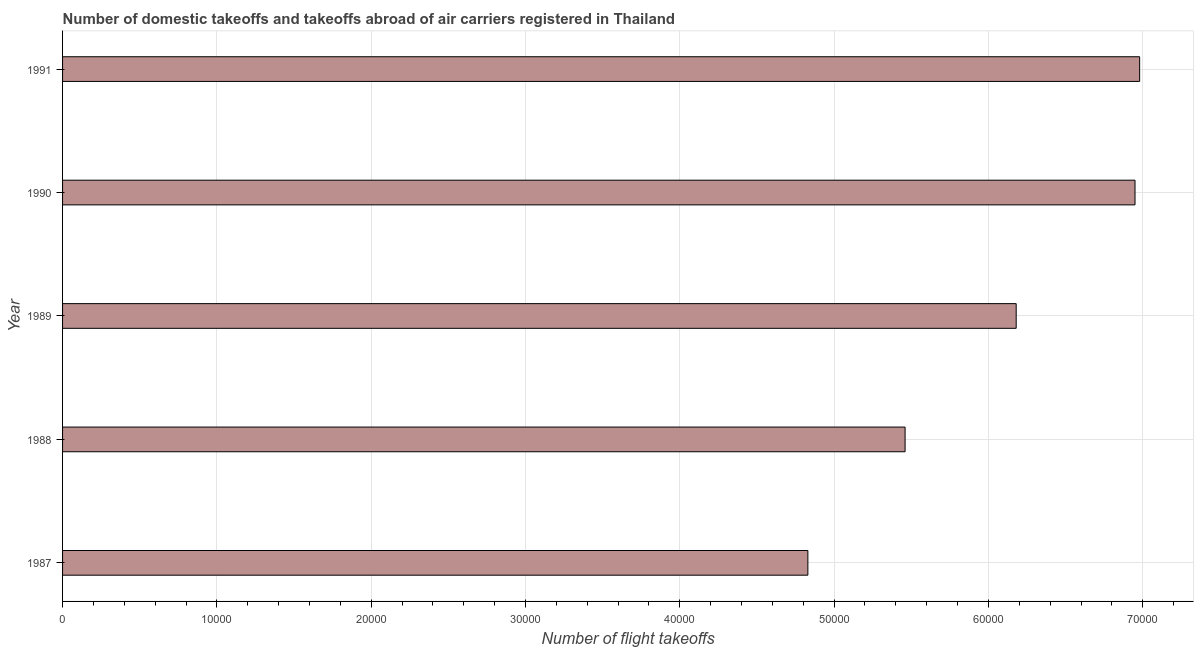Does the graph contain any zero values?
Provide a succinct answer. No. What is the title of the graph?
Keep it short and to the point. Number of domestic takeoffs and takeoffs abroad of air carriers registered in Thailand. What is the label or title of the X-axis?
Your answer should be very brief. Number of flight takeoffs. What is the number of flight takeoffs in 1990?
Offer a very short reply. 6.95e+04. Across all years, what is the maximum number of flight takeoffs?
Make the answer very short. 6.98e+04. Across all years, what is the minimum number of flight takeoffs?
Offer a terse response. 4.83e+04. In which year was the number of flight takeoffs maximum?
Provide a short and direct response. 1991. What is the sum of the number of flight takeoffs?
Offer a terse response. 3.04e+05. What is the difference between the number of flight takeoffs in 1988 and 1989?
Ensure brevity in your answer.  -7200. What is the average number of flight takeoffs per year?
Offer a terse response. 6.08e+04. What is the median number of flight takeoffs?
Keep it short and to the point. 6.18e+04. In how many years, is the number of flight takeoffs greater than 12000 ?
Make the answer very short. 5. What is the ratio of the number of flight takeoffs in 1989 to that in 1990?
Your response must be concise. 0.89. Is the difference between the number of flight takeoffs in 1987 and 1989 greater than the difference between any two years?
Ensure brevity in your answer.  No. What is the difference between the highest and the second highest number of flight takeoffs?
Provide a short and direct response. 300. Is the sum of the number of flight takeoffs in 1987 and 1988 greater than the maximum number of flight takeoffs across all years?
Offer a very short reply. Yes. What is the difference between the highest and the lowest number of flight takeoffs?
Offer a terse response. 2.15e+04. In how many years, is the number of flight takeoffs greater than the average number of flight takeoffs taken over all years?
Make the answer very short. 3. How many bars are there?
Give a very brief answer. 5. How many years are there in the graph?
Provide a succinct answer. 5. What is the Number of flight takeoffs of 1987?
Provide a succinct answer. 4.83e+04. What is the Number of flight takeoffs of 1988?
Offer a very short reply. 5.46e+04. What is the Number of flight takeoffs in 1989?
Provide a succinct answer. 6.18e+04. What is the Number of flight takeoffs in 1990?
Make the answer very short. 6.95e+04. What is the Number of flight takeoffs of 1991?
Ensure brevity in your answer.  6.98e+04. What is the difference between the Number of flight takeoffs in 1987 and 1988?
Provide a succinct answer. -6300. What is the difference between the Number of flight takeoffs in 1987 and 1989?
Your answer should be compact. -1.35e+04. What is the difference between the Number of flight takeoffs in 1987 and 1990?
Provide a succinct answer. -2.12e+04. What is the difference between the Number of flight takeoffs in 1987 and 1991?
Make the answer very short. -2.15e+04. What is the difference between the Number of flight takeoffs in 1988 and 1989?
Your response must be concise. -7200. What is the difference between the Number of flight takeoffs in 1988 and 1990?
Make the answer very short. -1.49e+04. What is the difference between the Number of flight takeoffs in 1988 and 1991?
Keep it short and to the point. -1.52e+04. What is the difference between the Number of flight takeoffs in 1989 and 1990?
Your response must be concise. -7700. What is the difference between the Number of flight takeoffs in 1989 and 1991?
Your answer should be compact. -8000. What is the difference between the Number of flight takeoffs in 1990 and 1991?
Make the answer very short. -300. What is the ratio of the Number of flight takeoffs in 1987 to that in 1988?
Give a very brief answer. 0.89. What is the ratio of the Number of flight takeoffs in 1987 to that in 1989?
Keep it short and to the point. 0.78. What is the ratio of the Number of flight takeoffs in 1987 to that in 1990?
Offer a terse response. 0.69. What is the ratio of the Number of flight takeoffs in 1987 to that in 1991?
Keep it short and to the point. 0.69. What is the ratio of the Number of flight takeoffs in 1988 to that in 1989?
Your answer should be very brief. 0.88. What is the ratio of the Number of flight takeoffs in 1988 to that in 1990?
Keep it short and to the point. 0.79. What is the ratio of the Number of flight takeoffs in 1988 to that in 1991?
Ensure brevity in your answer.  0.78. What is the ratio of the Number of flight takeoffs in 1989 to that in 1990?
Provide a succinct answer. 0.89. What is the ratio of the Number of flight takeoffs in 1989 to that in 1991?
Offer a very short reply. 0.89. 